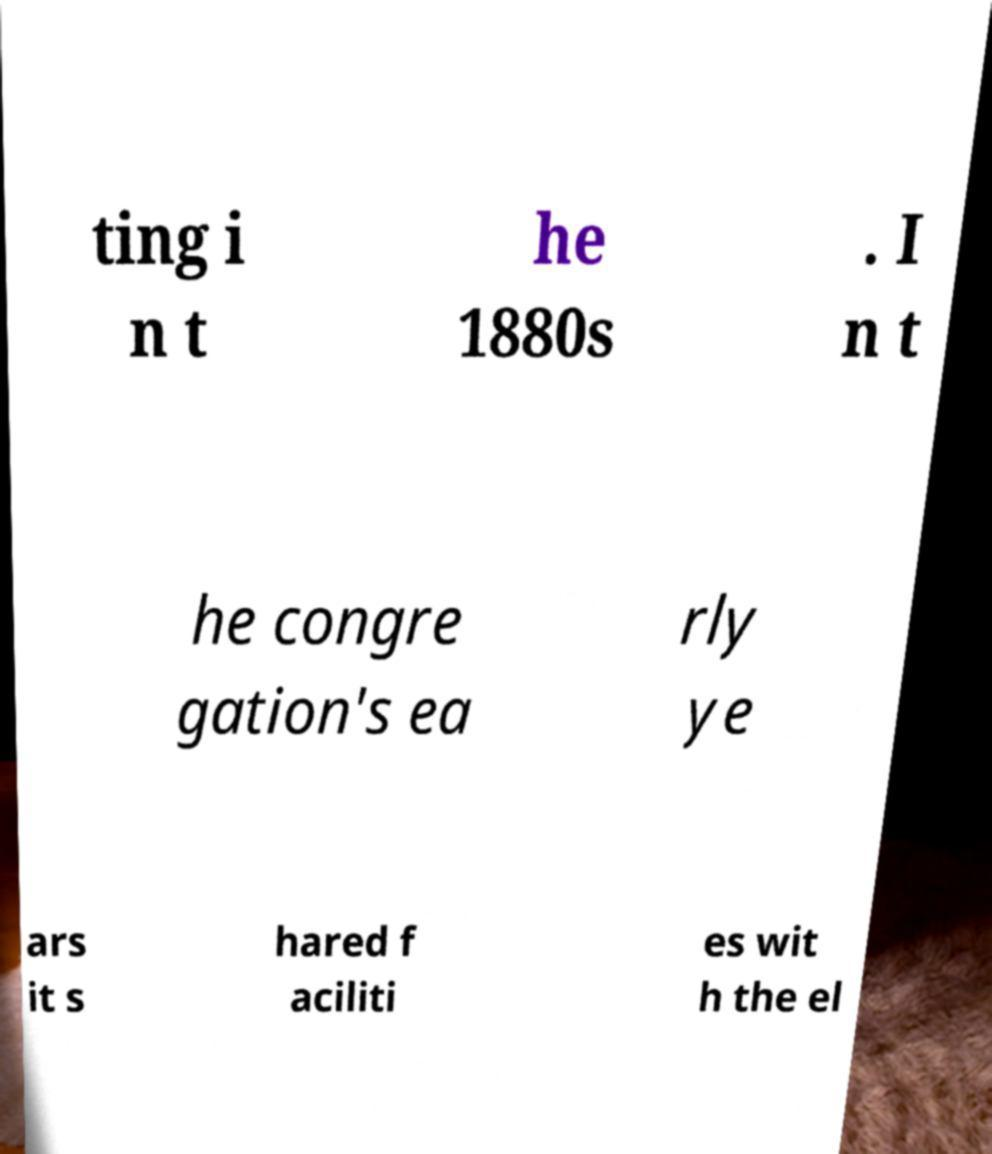I need the written content from this picture converted into text. Can you do that? ting i n t he 1880s . I n t he congre gation's ea rly ye ars it s hared f aciliti es wit h the el 